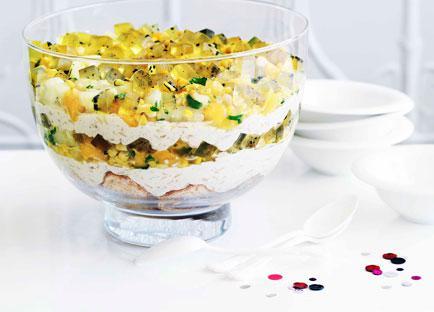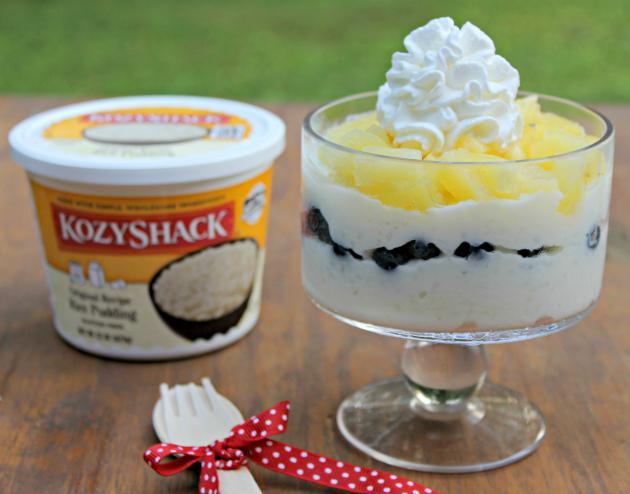The first image is the image on the left, the second image is the image on the right. Evaluate the accuracy of this statement regarding the images: "There is white flatware with a ribbon tied around it.". Is it true? Answer yes or no. Yes. 